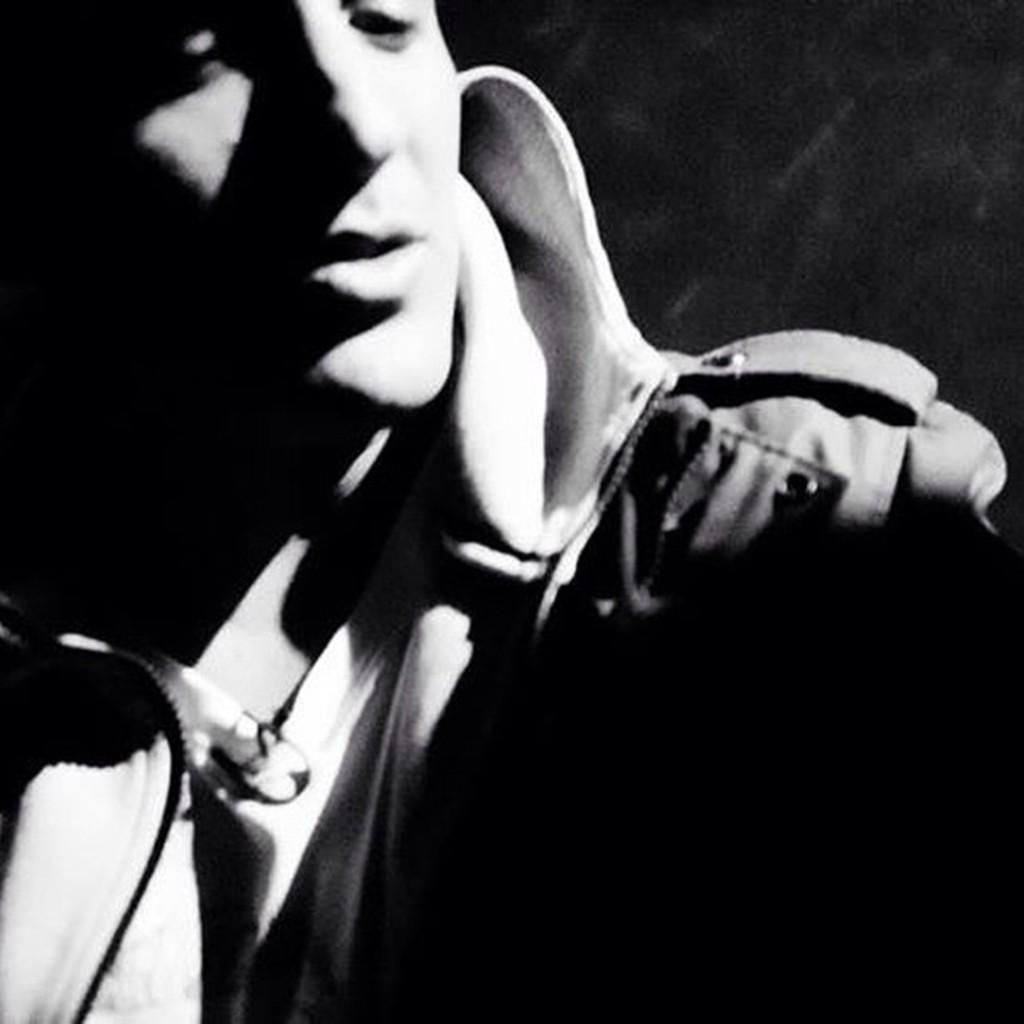Describe this image in one or two sentences. This is a black and white picture. I can see a person, and there is dark background. 